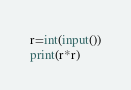<code> <loc_0><loc_0><loc_500><loc_500><_Python_>r=int(input())
print(r*r)</code> 